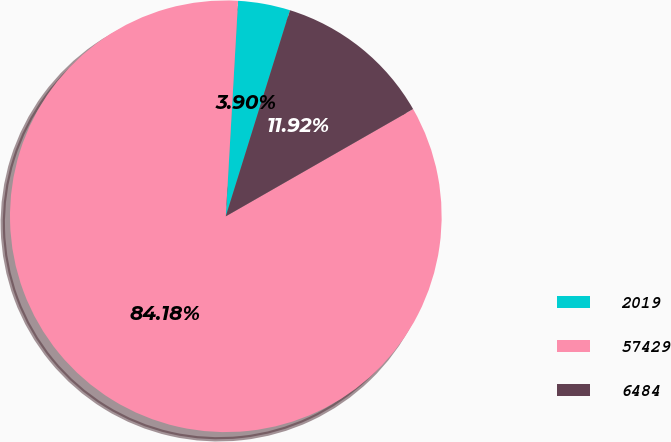Convert chart. <chart><loc_0><loc_0><loc_500><loc_500><pie_chart><fcel>2019<fcel>57429<fcel>6484<nl><fcel>3.9%<fcel>84.18%<fcel>11.92%<nl></chart> 